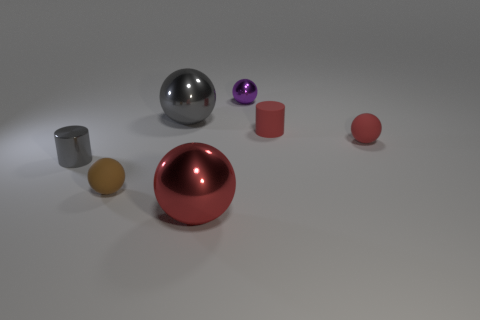There is a shiny ball that is behind the gray sphere; are there any small cylinders that are to the right of it?
Your answer should be compact. Yes. What number of other things are there of the same color as the tiny rubber cylinder?
Give a very brief answer. 2. What is the color of the metallic cylinder?
Keep it short and to the point. Gray. How big is the metal object that is to the right of the small gray cylinder and in front of the gray shiny ball?
Offer a very short reply. Large. What number of objects are either tiny brown rubber things in front of the small purple metallic object or small brown matte things?
Make the answer very short. 1. There is a small brown thing that is the same material as the red cylinder; what is its shape?
Make the answer very short. Sphere. What shape is the brown thing?
Keep it short and to the point. Sphere. What is the color of the small thing that is both to the left of the small metallic sphere and right of the tiny gray cylinder?
Your answer should be very brief. Brown. There is another metallic object that is the same size as the purple metal thing; what is its shape?
Your response must be concise. Cylinder. Are there any small brown things of the same shape as the large red shiny thing?
Your answer should be compact. Yes. 